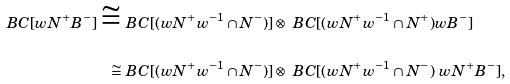Convert formula to latex. <formula><loc_0><loc_0><loc_500><loc_500>\ B C [ w N ^ { + } B ^ { - } ] \cong & \ B C [ ( w N ^ { + } w ^ { - 1 } \cap N ^ { - } ) ] \otimes \ B C [ ( w N ^ { + } w ^ { - 1 } \cap N ^ { + } ) w B ^ { - } ] \\ \cong & \ B C [ ( w N ^ { + } w ^ { - 1 } \cap N ^ { - } ) ] \otimes \ B C [ ( w N ^ { + } w ^ { - 1 } \cap N ^ { - } ) \ w N ^ { + } B ^ { - } ] ,</formula> 